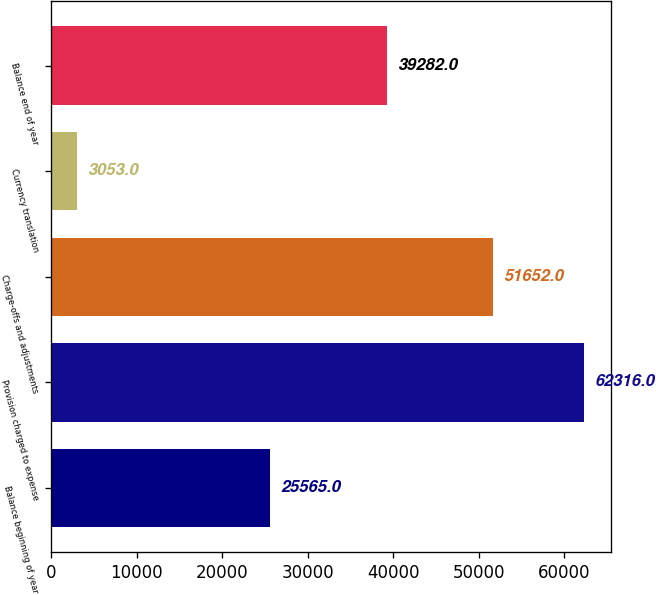<chart> <loc_0><loc_0><loc_500><loc_500><bar_chart><fcel>Balance beginning of year<fcel>Provision charged to expense<fcel>Charge-offs and adjustments<fcel>Currency translation<fcel>Balance end of year<nl><fcel>25565<fcel>62316<fcel>51652<fcel>3053<fcel>39282<nl></chart> 